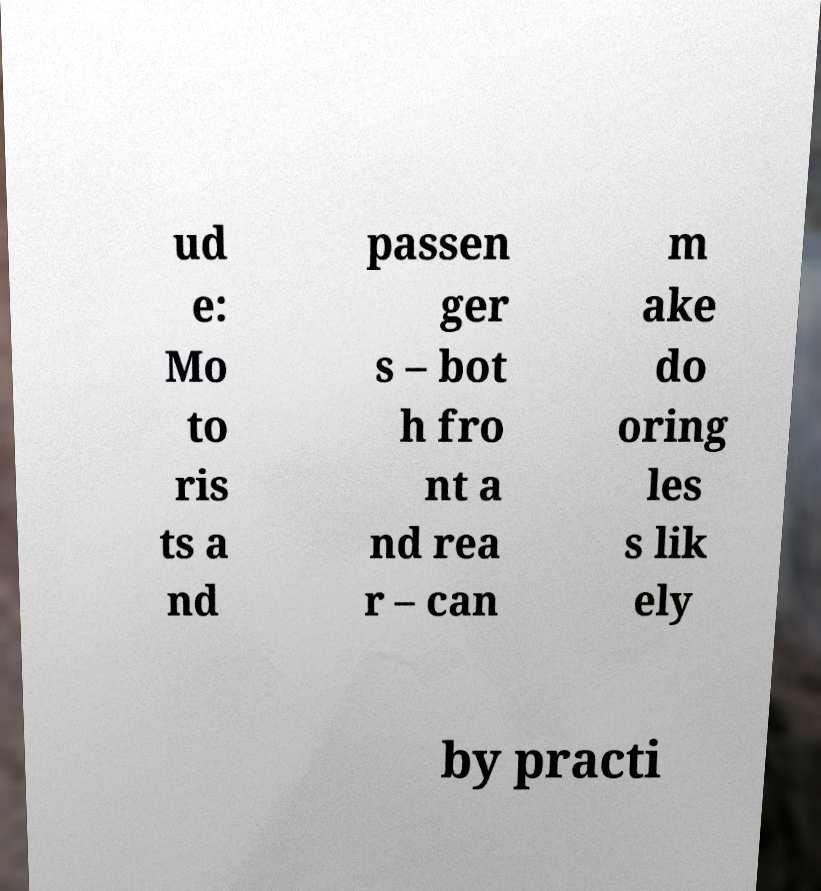Could you extract and type out the text from this image? ud e: Mo to ris ts a nd passen ger s – bot h fro nt a nd rea r – can m ake do oring les s lik ely by practi 